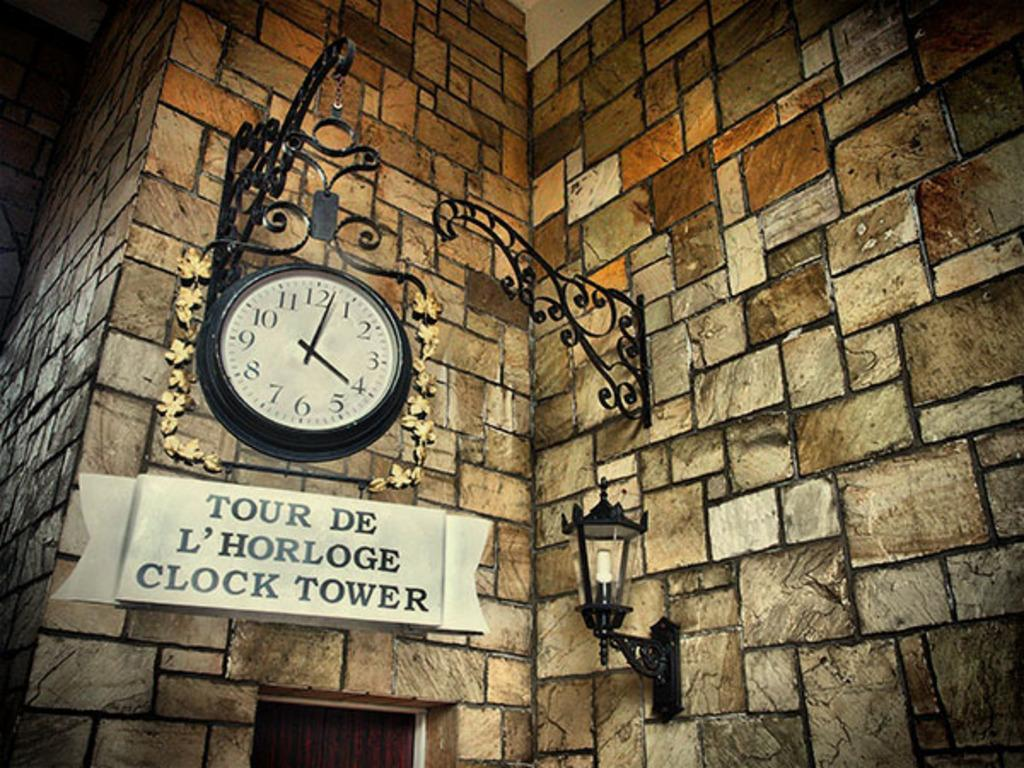<image>
Relay a brief, clear account of the picture shown. A large clock that hangs over a "Tour De L'Horloge Clock Tower" sign. 